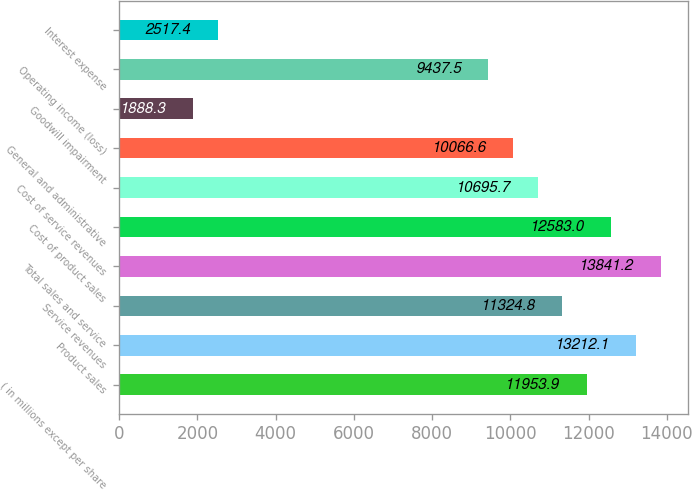<chart> <loc_0><loc_0><loc_500><loc_500><bar_chart><fcel>( in millions except per share<fcel>Product sales<fcel>Service revenues<fcel>Total sales and service<fcel>Cost of product sales<fcel>Cost of service revenues<fcel>General and administrative<fcel>Goodwill impairment<fcel>Operating income (loss)<fcel>Interest expense<nl><fcel>11953.9<fcel>13212.1<fcel>11324.8<fcel>13841.2<fcel>12583<fcel>10695.7<fcel>10066.6<fcel>1888.3<fcel>9437.5<fcel>2517.4<nl></chart> 